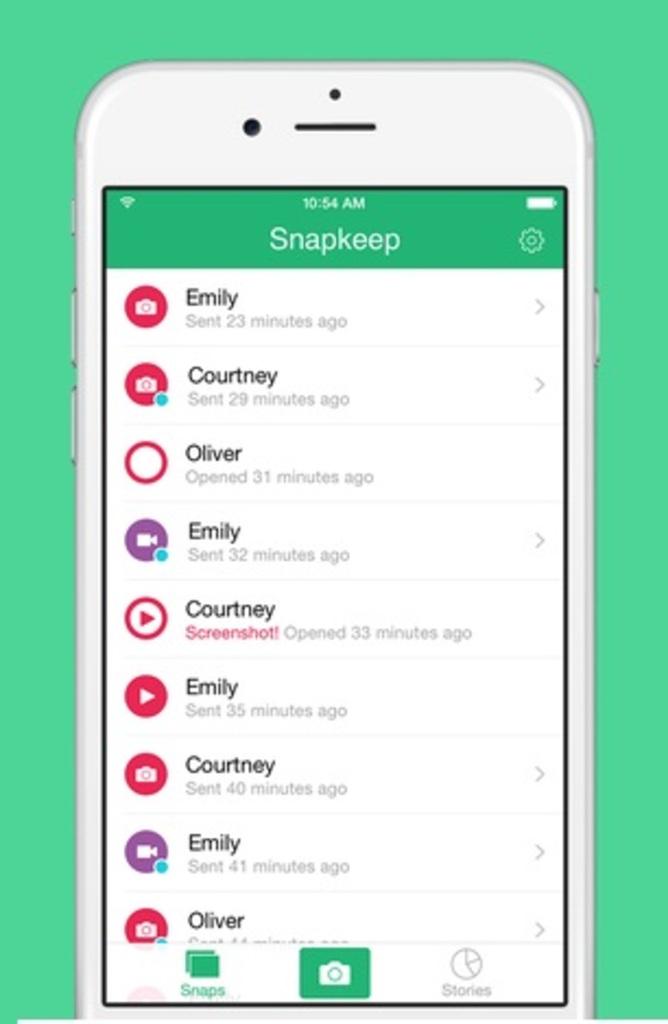When was oliver's last message opened?
Your response must be concise. 31 minutes ago. 